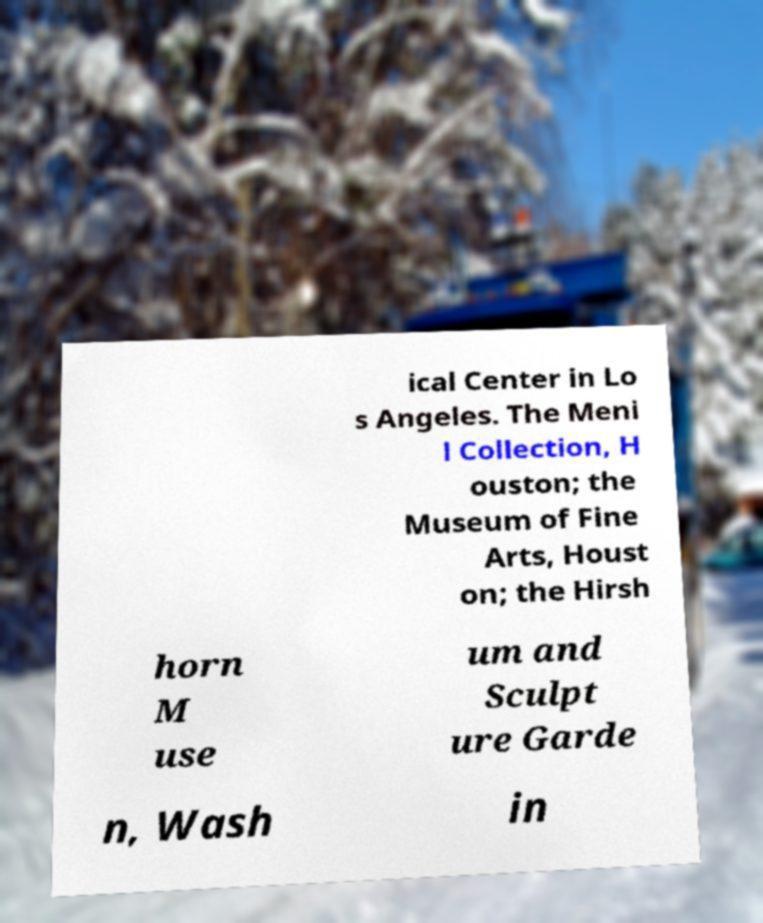Can you read and provide the text displayed in the image?This photo seems to have some interesting text. Can you extract and type it out for me? ical Center in Lo s Angeles. The Meni l Collection, H ouston; the Museum of Fine Arts, Houst on; the Hirsh horn M use um and Sculpt ure Garde n, Wash in 